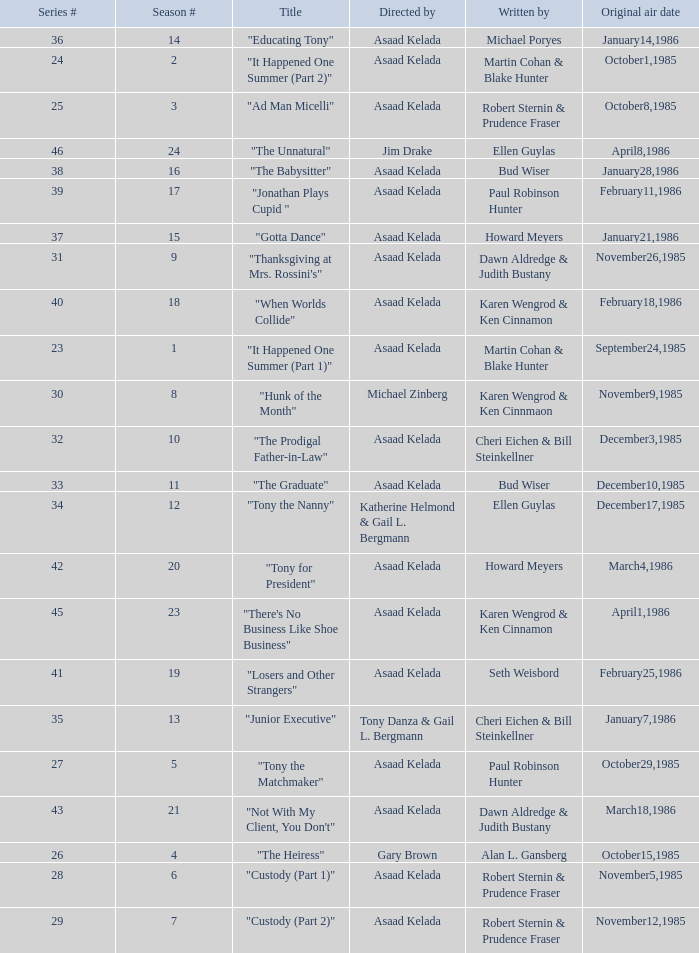What is the date of the episode written by Michael Poryes? January14,1986. 